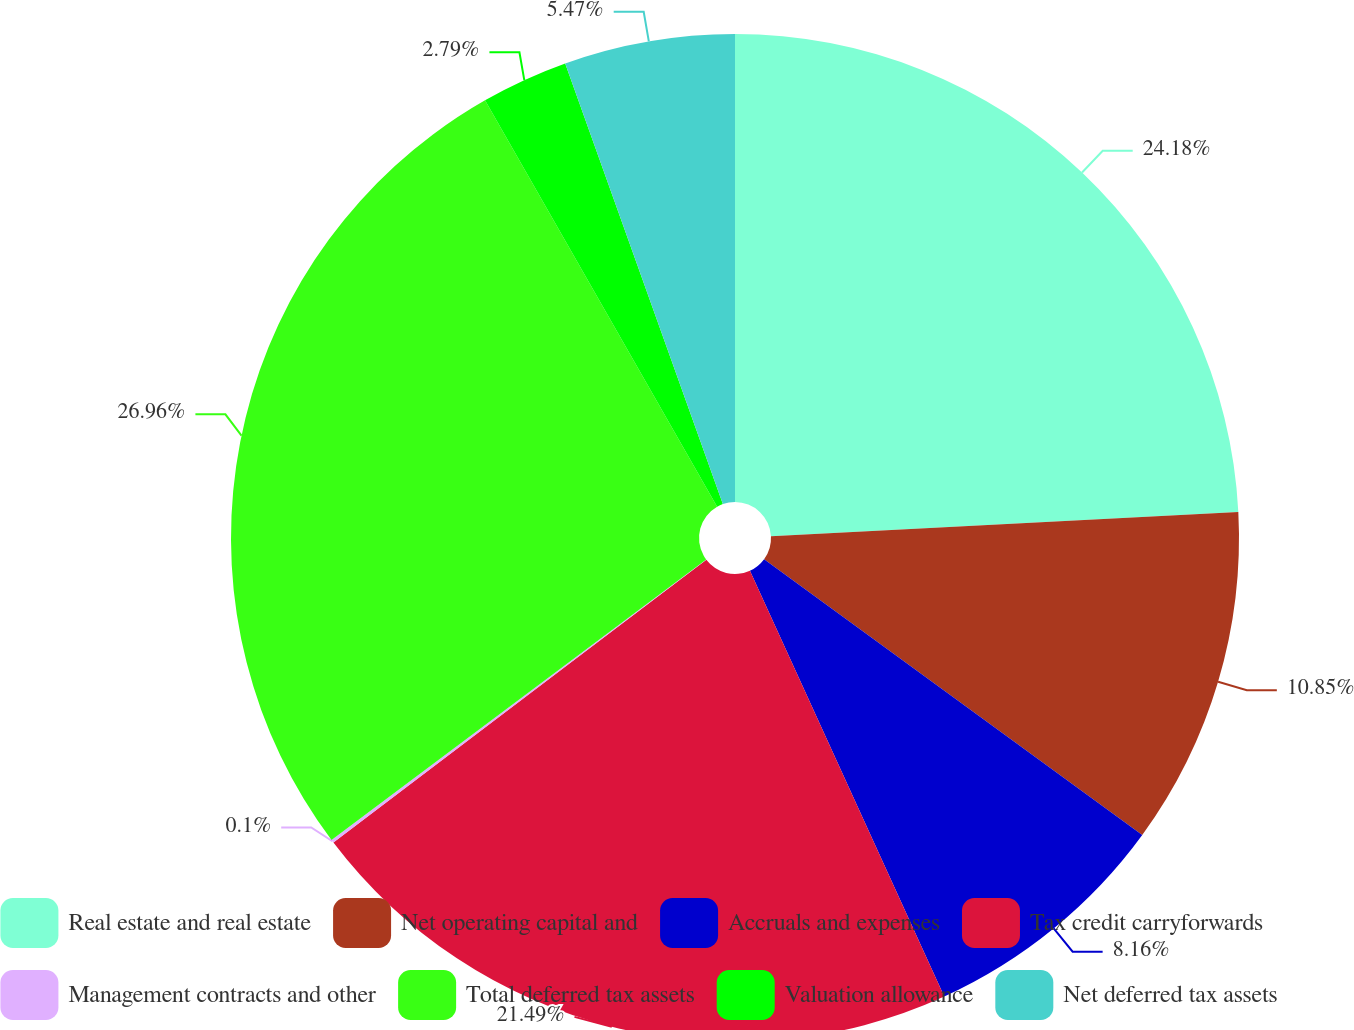<chart> <loc_0><loc_0><loc_500><loc_500><pie_chart><fcel>Real estate and real estate<fcel>Net operating capital and<fcel>Accruals and expenses<fcel>Tax credit carryforwards<fcel>Management contracts and other<fcel>Total deferred tax assets<fcel>Valuation allowance<fcel>Net deferred tax assets<nl><fcel>24.18%<fcel>10.85%<fcel>8.16%<fcel>21.49%<fcel>0.1%<fcel>26.97%<fcel>2.79%<fcel>5.47%<nl></chart> 